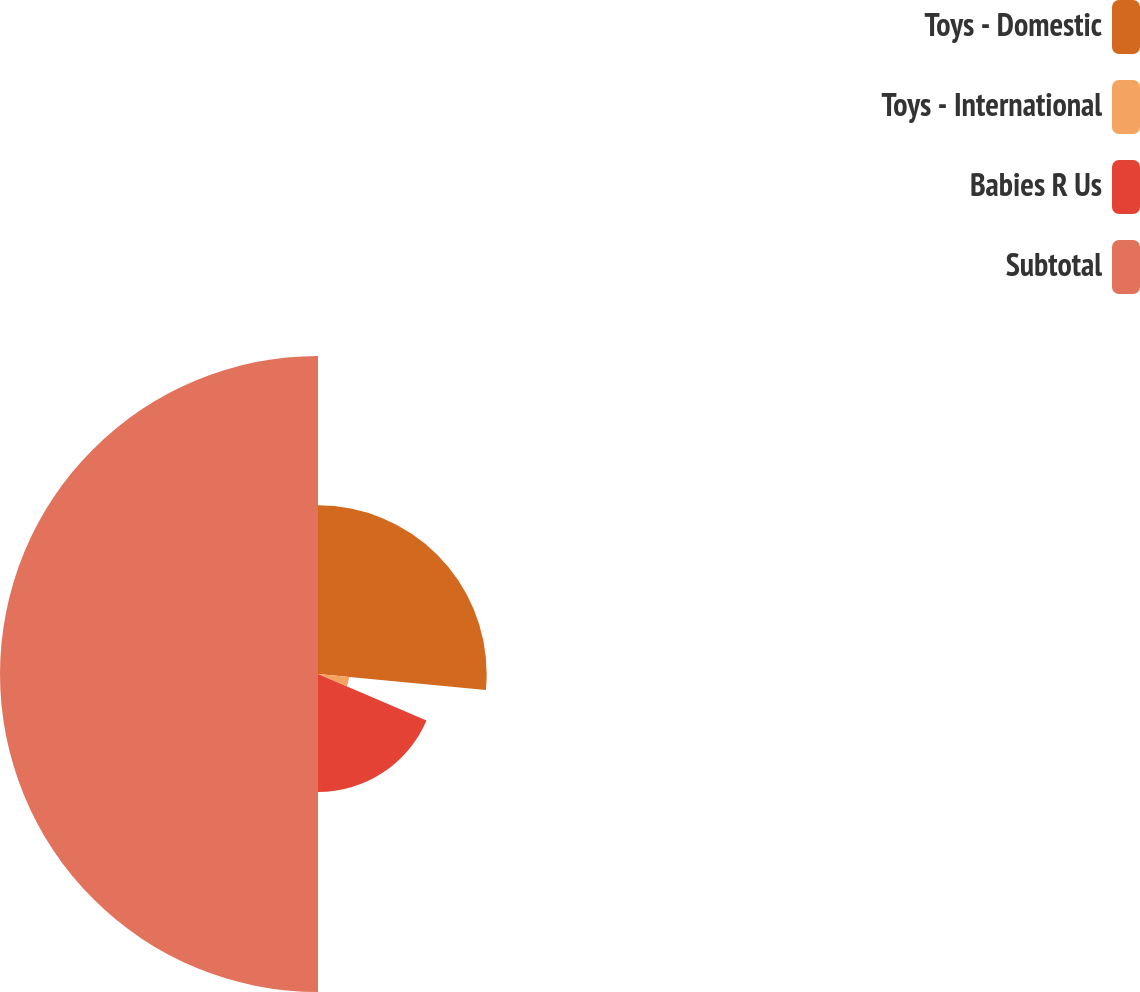Convert chart to OTSL. <chart><loc_0><loc_0><loc_500><loc_500><pie_chart><fcel>Toys - Domestic<fcel>Toys - International<fcel>Babies R Us<fcel>Subtotal<nl><fcel>26.52%<fcel>4.92%<fcel>18.56%<fcel>50.0%<nl></chart> 